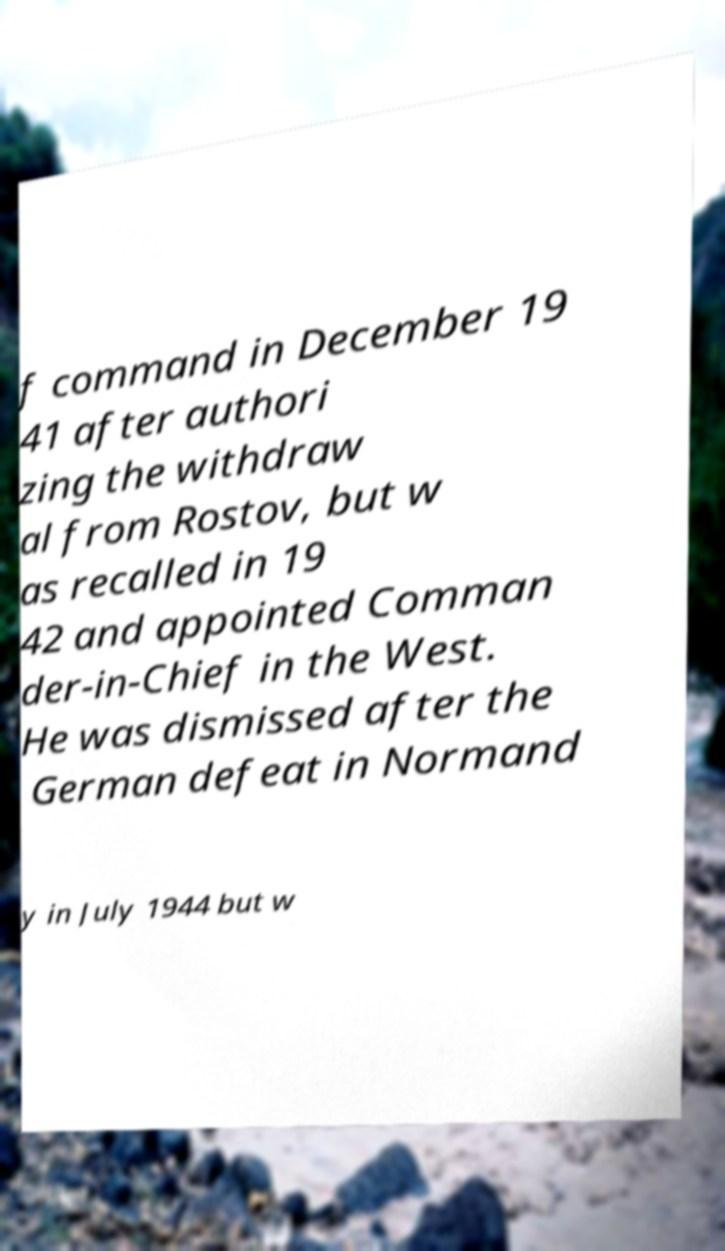Can you read and provide the text displayed in the image?This photo seems to have some interesting text. Can you extract and type it out for me? f command in December 19 41 after authori zing the withdraw al from Rostov, but w as recalled in 19 42 and appointed Comman der-in-Chief in the West. He was dismissed after the German defeat in Normand y in July 1944 but w 